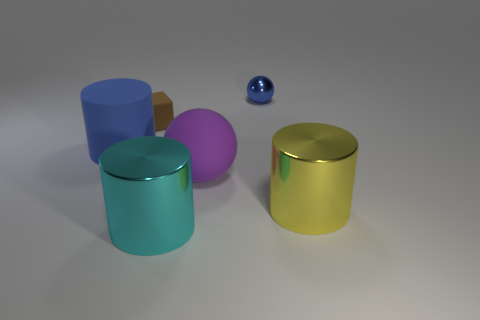What number of tiny balls are the same color as the cube?
Keep it short and to the point. 0. What number of objects are either brown cubes that are behind the purple matte object or things that are in front of the shiny ball?
Ensure brevity in your answer.  5. Are there fewer blue objects that are on the left side of the tiny blue metallic ball than small brown blocks?
Ensure brevity in your answer.  No. Are there any cyan metallic cylinders of the same size as the block?
Provide a short and direct response. No. The shiny sphere is what color?
Provide a short and direct response. Blue. Is the size of the blue matte cylinder the same as the purple ball?
Ensure brevity in your answer.  Yes. How many objects are blue rubber balls or big things?
Your answer should be compact. 4. Are there the same number of big shiny things behind the large blue object and cyan shiny objects?
Ensure brevity in your answer.  No. There is a large cylinder that is in front of the large cylinder on the right side of the big rubber sphere; is there a big cyan cylinder that is to the left of it?
Provide a succinct answer. No. There is a sphere that is the same material as the small brown thing; what color is it?
Make the answer very short. Purple. 